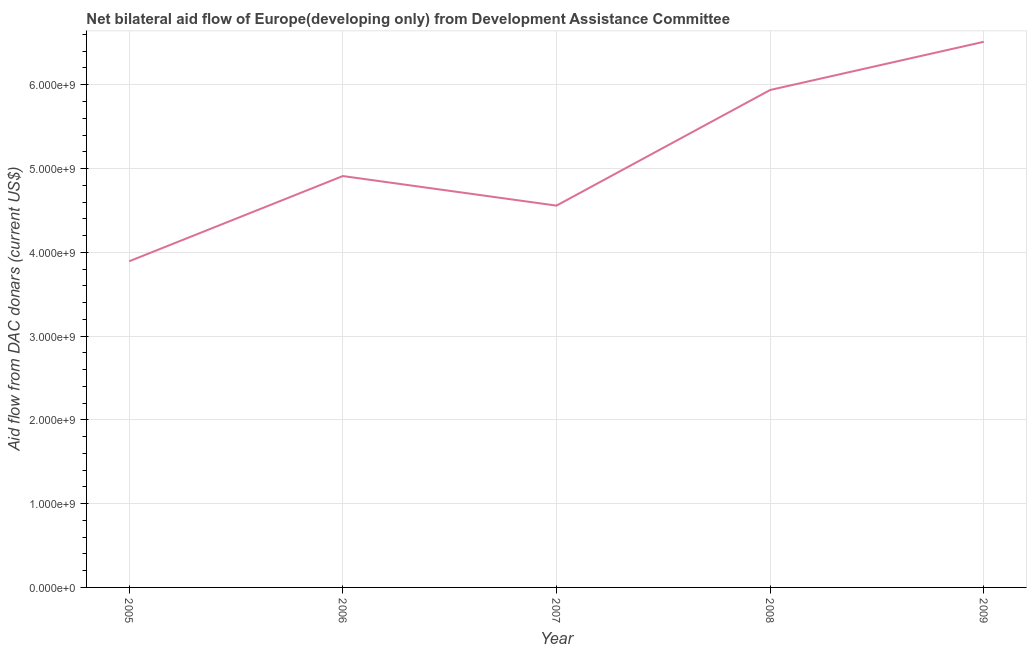What is the net bilateral aid flows from dac donors in 2006?
Provide a succinct answer. 4.91e+09. Across all years, what is the maximum net bilateral aid flows from dac donors?
Offer a terse response. 6.51e+09. Across all years, what is the minimum net bilateral aid flows from dac donors?
Ensure brevity in your answer.  3.89e+09. In which year was the net bilateral aid flows from dac donors maximum?
Your response must be concise. 2009. In which year was the net bilateral aid flows from dac donors minimum?
Keep it short and to the point. 2005. What is the sum of the net bilateral aid flows from dac donors?
Give a very brief answer. 2.58e+1. What is the difference between the net bilateral aid flows from dac donors in 2006 and 2009?
Keep it short and to the point. -1.60e+09. What is the average net bilateral aid flows from dac donors per year?
Offer a terse response. 5.16e+09. What is the median net bilateral aid flows from dac donors?
Make the answer very short. 4.91e+09. In how many years, is the net bilateral aid flows from dac donors greater than 3800000000 US$?
Give a very brief answer. 5. Do a majority of the years between 2006 and 2005 (inclusive) have net bilateral aid flows from dac donors greater than 2200000000 US$?
Your answer should be very brief. No. What is the ratio of the net bilateral aid flows from dac donors in 2006 to that in 2007?
Give a very brief answer. 1.08. What is the difference between the highest and the second highest net bilateral aid flows from dac donors?
Keep it short and to the point. 5.75e+08. Is the sum of the net bilateral aid flows from dac donors in 2005 and 2006 greater than the maximum net bilateral aid flows from dac donors across all years?
Offer a very short reply. Yes. What is the difference between the highest and the lowest net bilateral aid flows from dac donors?
Offer a terse response. 2.62e+09. Does the net bilateral aid flows from dac donors monotonically increase over the years?
Provide a short and direct response. No. How many lines are there?
Provide a succinct answer. 1. How many years are there in the graph?
Your answer should be very brief. 5. Are the values on the major ticks of Y-axis written in scientific E-notation?
Provide a short and direct response. Yes. Does the graph contain any zero values?
Make the answer very short. No. What is the title of the graph?
Provide a short and direct response. Net bilateral aid flow of Europe(developing only) from Development Assistance Committee. What is the label or title of the Y-axis?
Make the answer very short. Aid flow from DAC donars (current US$). What is the Aid flow from DAC donars (current US$) in 2005?
Give a very brief answer. 3.89e+09. What is the Aid flow from DAC donars (current US$) of 2006?
Make the answer very short. 4.91e+09. What is the Aid flow from DAC donars (current US$) of 2007?
Your answer should be compact. 4.56e+09. What is the Aid flow from DAC donars (current US$) in 2008?
Provide a short and direct response. 5.94e+09. What is the Aid flow from DAC donars (current US$) in 2009?
Your response must be concise. 6.51e+09. What is the difference between the Aid flow from DAC donars (current US$) in 2005 and 2006?
Keep it short and to the point. -1.02e+09. What is the difference between the Aid flow from DAC donars (current US$) in 2005 and 2007?
Provide a short and direct response. -6.64e+08. What is the difference between the Aid flow from DAC donars (current US$) in 2005 and 2008?
Give a very brief answer. -2.04e+09. What is the difference between the Aid flow from DAC donars (current US$) in 2005 and 2009?
Your answer should be very brief. -2.62e+09. What is the difference between the Aid flow from DAC donars (current US$) in 2006 and 2007?
Your answer should be very brief. 3.53e+08. What is the difference between the Aid flow from DAC donars (current US$) in 2006 and 2008?
Make the answer very short. -1.03e+09. What is the difference between the Aid flow from DAC donars (current US$) in 2006 and 2009?
Your answer should be compact. -1.60e+09. What is the difference between the Aid flow from DAC donars (current US$) in 2007 and 2008?
Provide a short and direct response. -1.38e+09. What is the difference between the Aid flow from DAC donars (current US$) in 2007 and 2009?
Keep it short and to the point. -1.96e+09. What is the difference between the Aid flow from DAC donars (current US$) in 2008 and 2009?
Offer a terse response. -5.75e+08. What is the ratio of the Aid flow from DAC donars (current US$) in 2005 to that in 2006?
Offer a very short reply. 0.79. What is the ratio of the Aid flow from DAC donars (current US$) in 2005 to that in 2007?
Offer a terse response. 0.85. What is the ratio of the Aid flow from DAC donars (current US$) in 2005 to that in 2008?
Make the answer very short. 0.66. What is the ratio of the Aid flow from DAC donars (current US$) in 2005 to that in 2009?
Your answer should be compact. 0.6. What is the ratio of the Aid flow from DAC donars (current US$) in 2006 to that in 2007?
Provide a succinct answer. 1.08. What is the ratio of the Aid flow from DAC donars (current US$) in 2006 to that in 2008?
Give a very brief answer. 0.83. What is the ratio of the Aid flow from DAC donars (current US$) in 2006 to that in 2009?
Offer a very short reply. 0.75. What is the ratio of the Aid flow from DAC donars (current US$) in 2007 to that in 2008?
Offer a terse response. 0.77. What is the ratio of the Aid flow from DAC donars (current US$) in 2008 to that in 2009?
Offer a terse response. 0.91. 